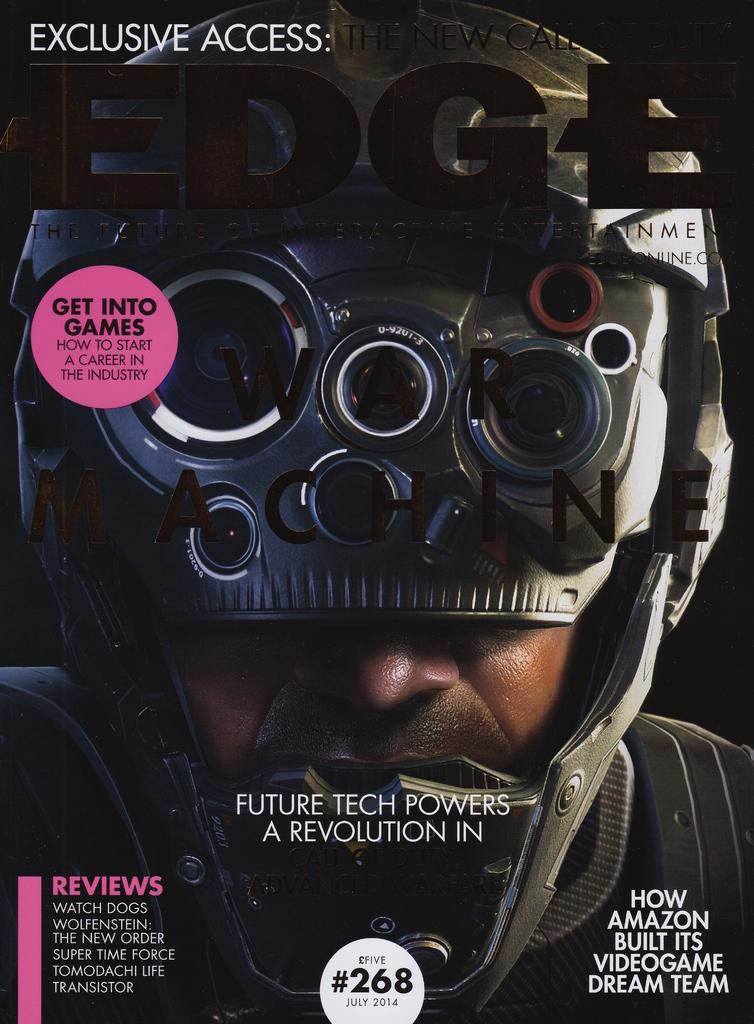What is present in the image? There is a man in the image. What is the man wearing on his head? The man is wearing a helmet. Is there any text visible in the image? Yes, there is some text visible in the image. What type of poison is the man holding in the image? There is no poison present in the image; the man is wearing a helmet. What type of heart is visible on the man's chest in the image? There is no heart visible on the man's chest in the image. 